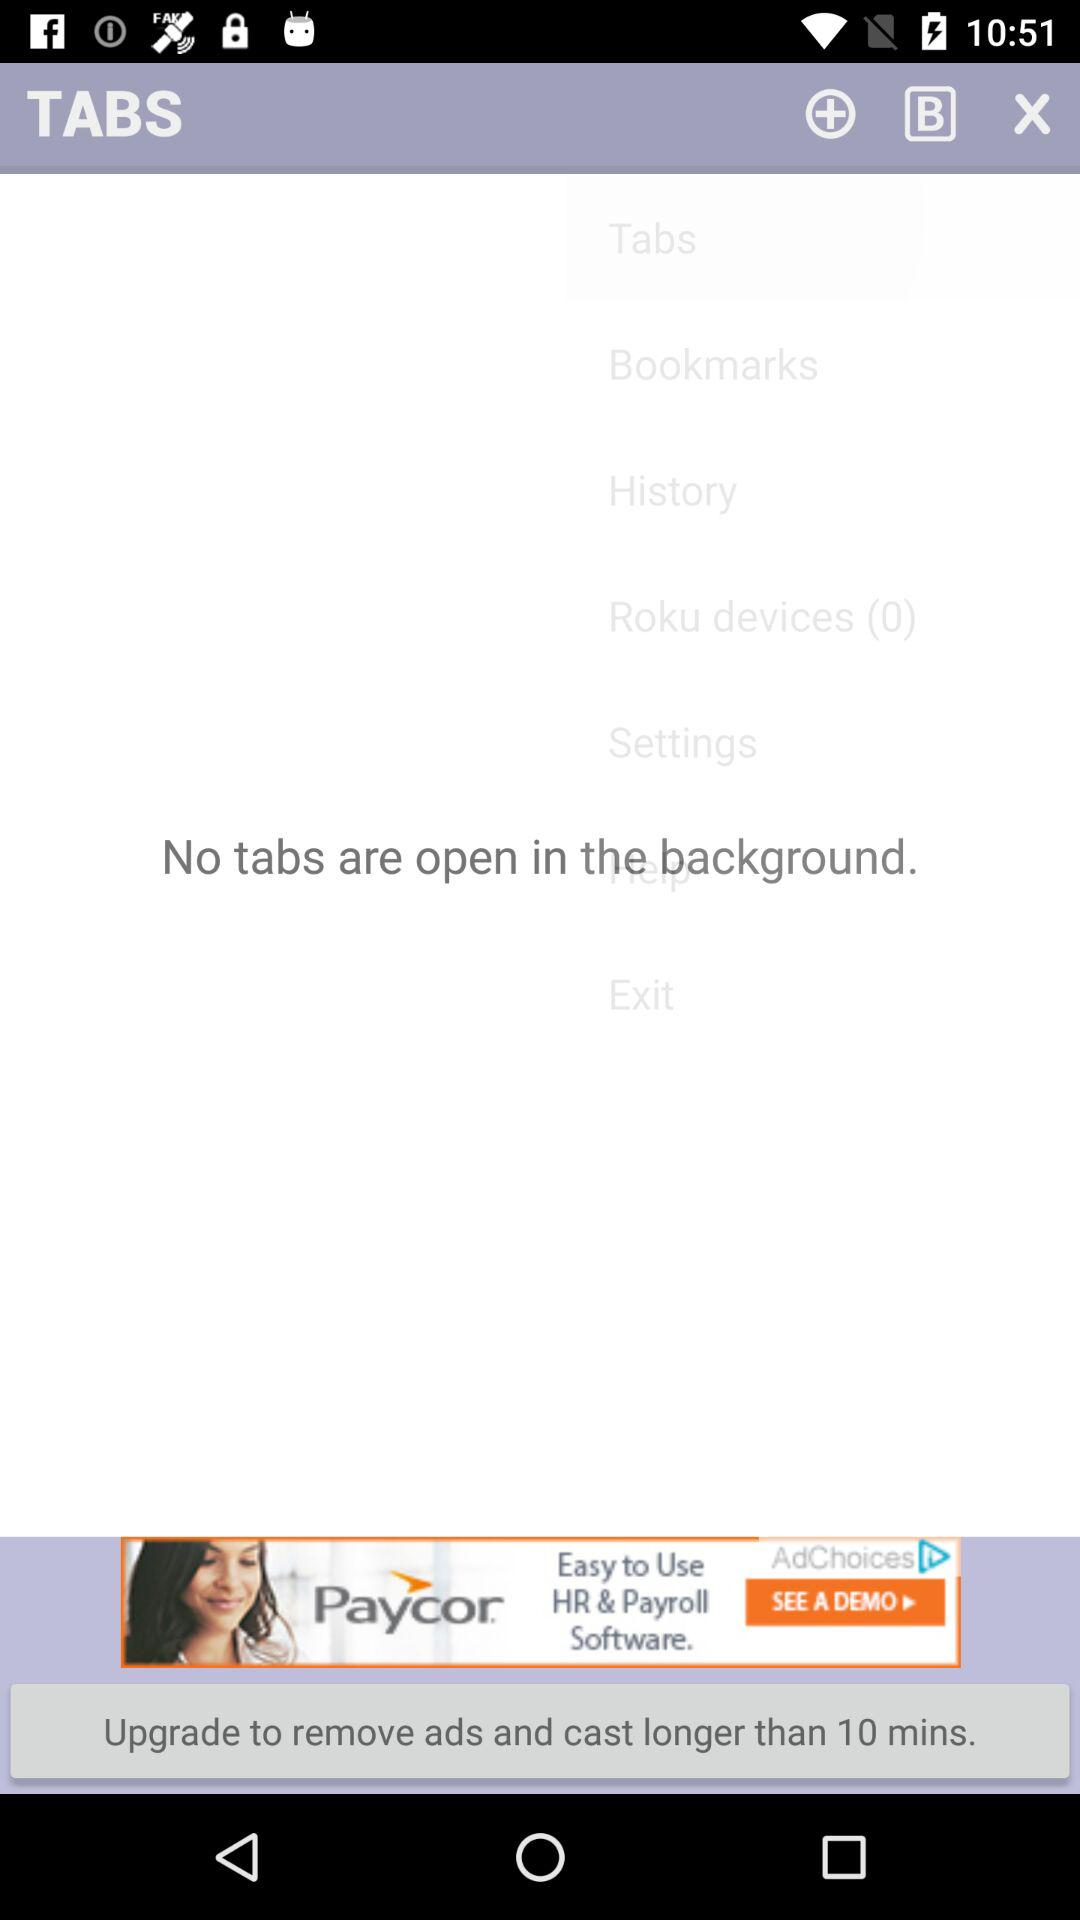Is there any tab open in the background? There is no tab open in the background. 